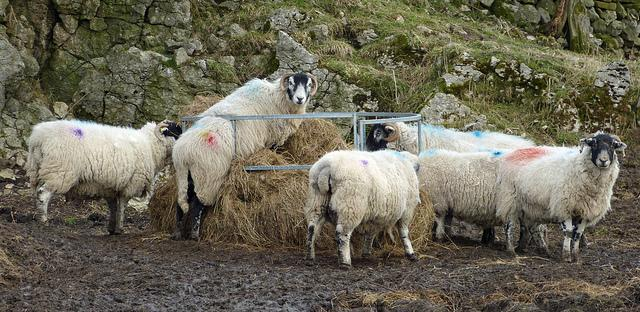What word is related to these animals?

Choices:
A) beef
B) ewe
C) kitten
D) joey ewe 